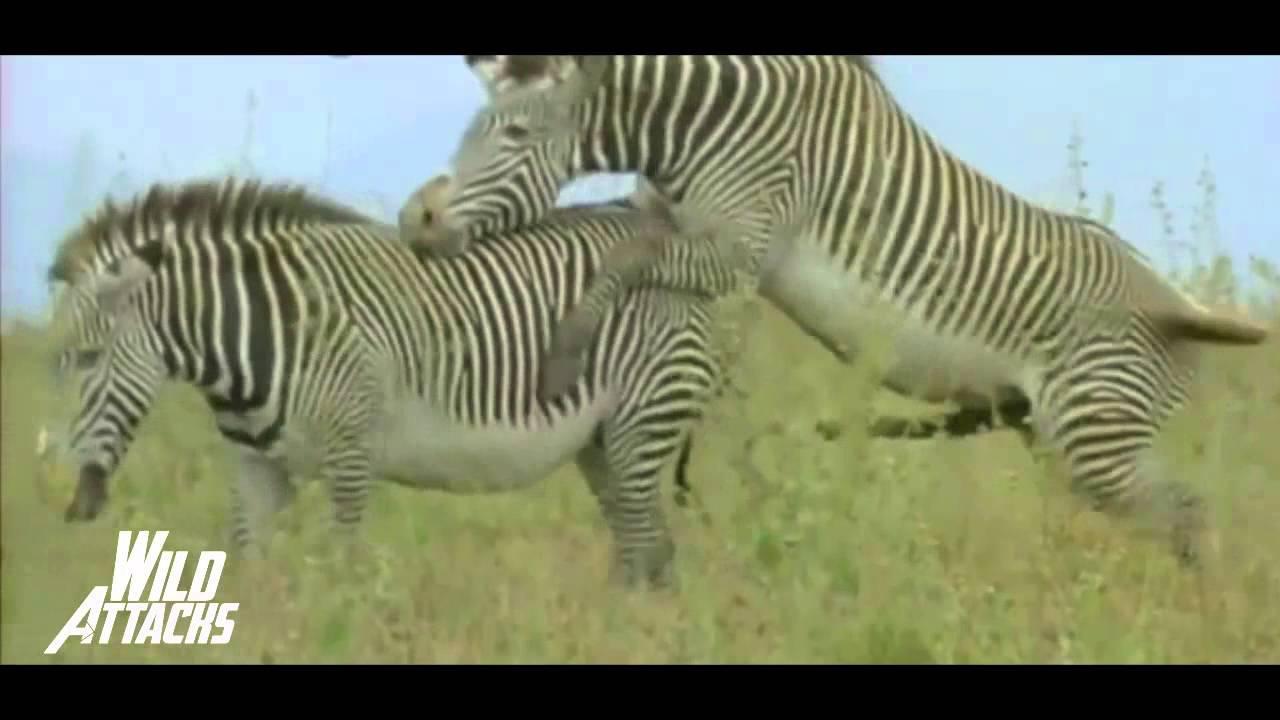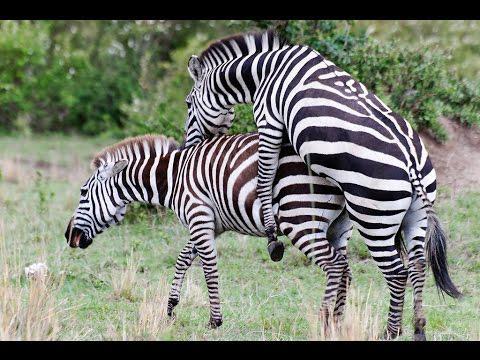The first image is the image on the left, the second image is the image on the right. For the images shown, is this caption "The left and right image contains the same number of adult zebras." true? Answer yes or no. Yes. The first image is the image on the left, the second image is the image on the right. For the images displayed, is the sentence "The left image shows a smaller hooved animal next to a bigger hooved animal, and the right image shows one zebra with its front legs over another zebra's back." factually correct? Answer yes or no. No. 